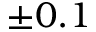Convert formula to latex. <formula><loc_0><loc_0><loc_500><loc_500>\pm 0 . 1</formula> 